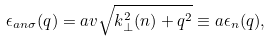Convert formula to latex. <formula><loc_0><loc_0><loc_500><loc_500>\epsilon _ { a n \sigma } ( q ) = a v \sqrt { k ^ { 2 } _ { \perp } ( n ) + q ^ { 2 } } \equiv a \epsilon _ { n } ( q ) ,</formula> 